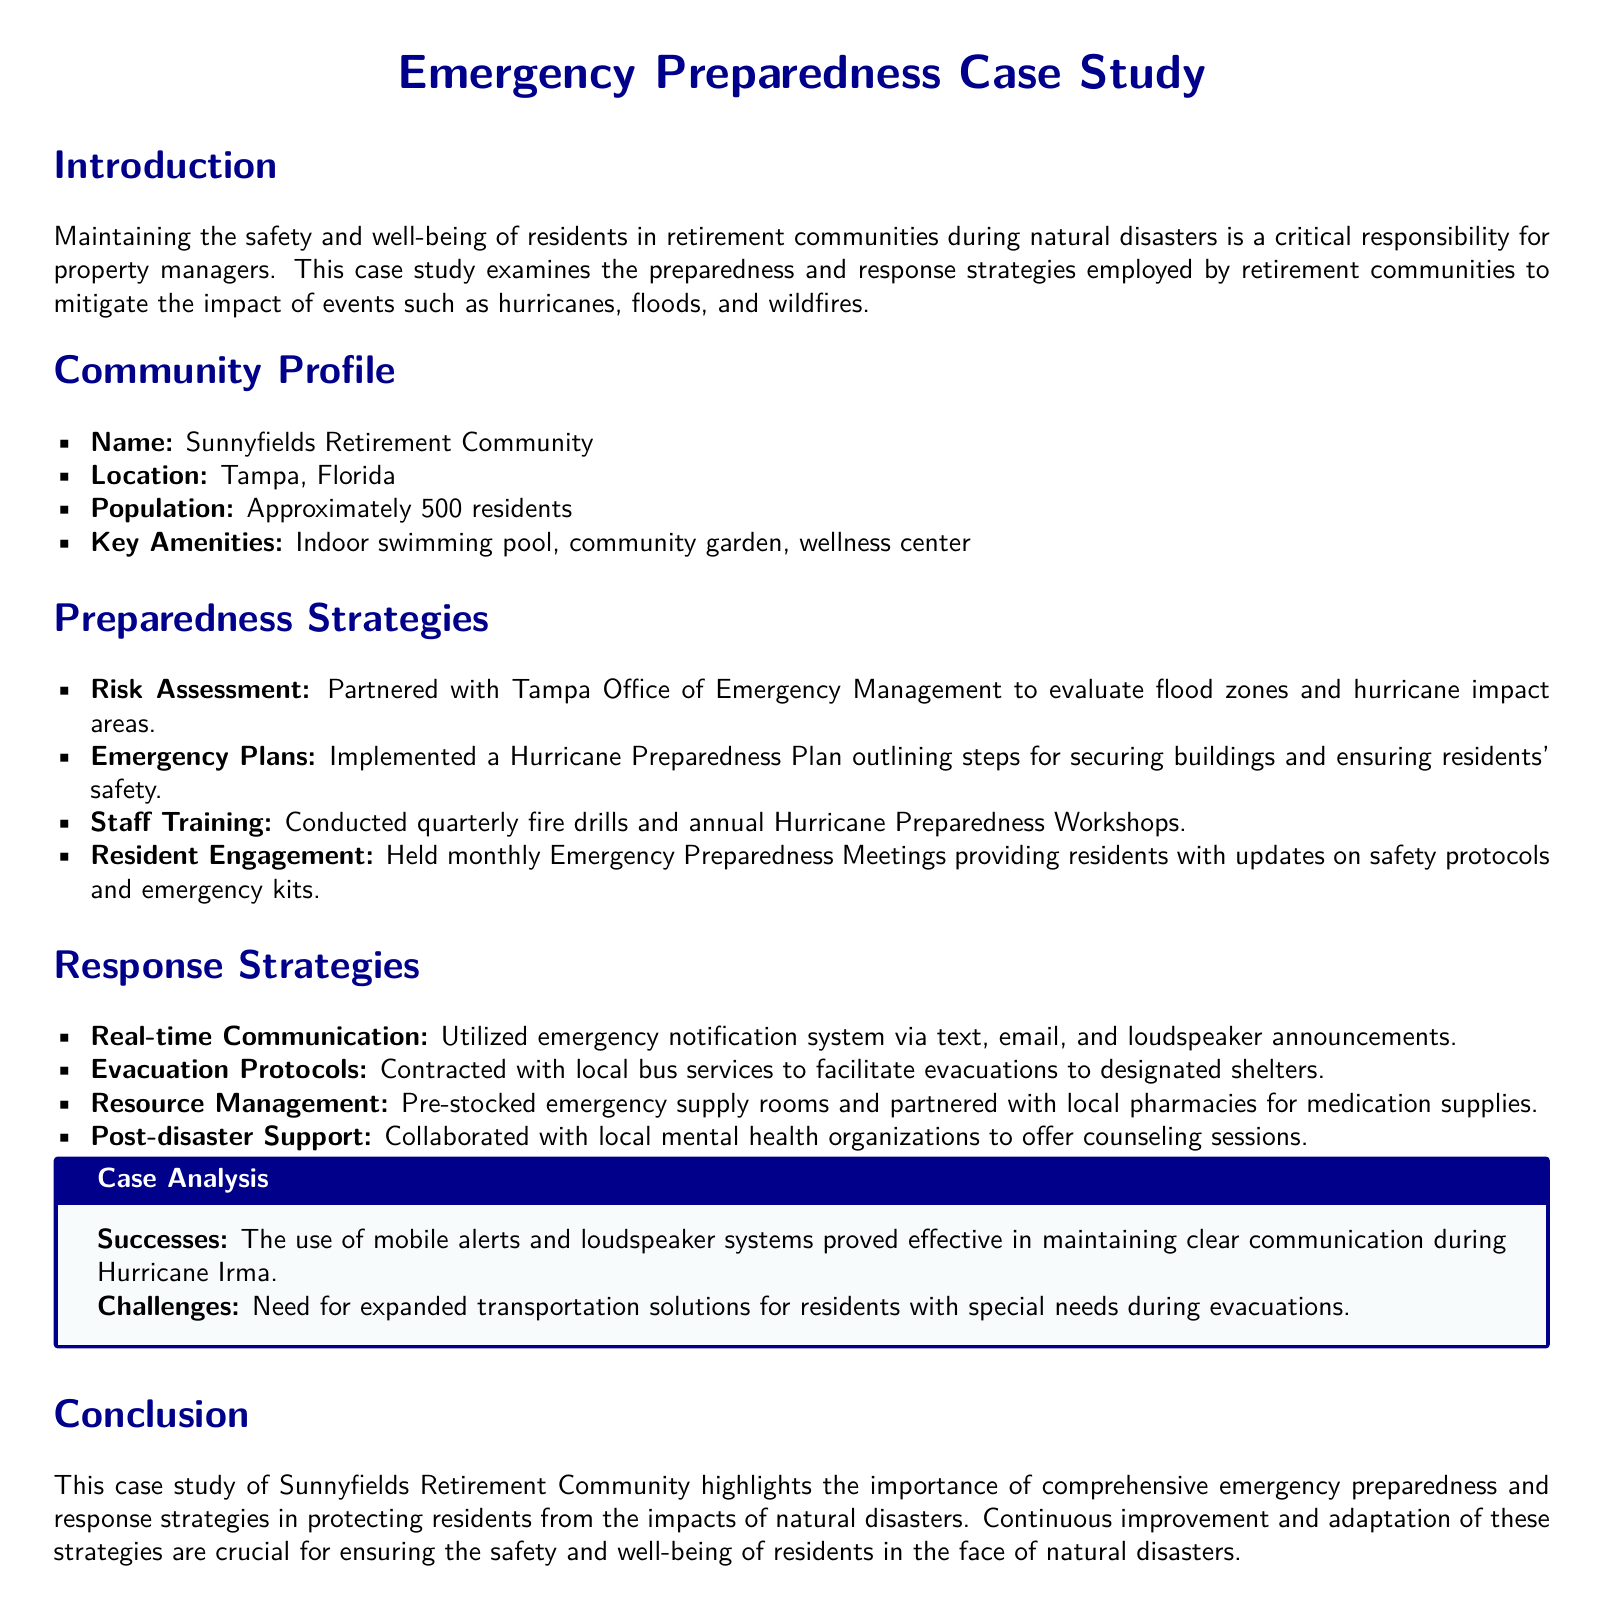What is the name of the retirement community? The name of the retirement community is mentioned in the introduction section of the document.
Answer: Sunnyfields Retirement Community What is the location of Sunnyfields Retirement Community? The location is specified in the community profile section.
Answer: Tampa, Florida How many residents are approximately in the community? The approximate population is provided in the community profile.
Answer: 500 residents What emergency plan has been implemented? The specific emergency plan is outlined under the preparedness strategies section.
Answer: Hurricane Preparedness Plan How often are staff drills conducted? The frequency of staff training is mentioned in the preparedness strategies section.
Answer: Quarterly What communication method was used during Hurricane Irma? The method of communication during the hurricane is highlighted in the successes of the case analysis.
Answer: Mobile alerts and loudspeaker systems What was identified as a challenge during evacuations? The challenges faced during evacuations are outlined in the challenges section of the case analysis.
Answer: Expanded transportation solutions With whom did the community collaborate for post-disaster support? The collaboration for post-disaster support is listed in the response strategies section.
Answer: Local mental health organizations What type of workshops are conducted annually? The type of workshops provided to staff is mentioned in the preparedness strategies section.
Answer: Hurricane Preparedness Workshops 